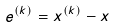<formula> <loc_0><loc_0><loc_500><loc_500>e ^ { ( k ) } = x ^ { ( k ) } - x</formula> 